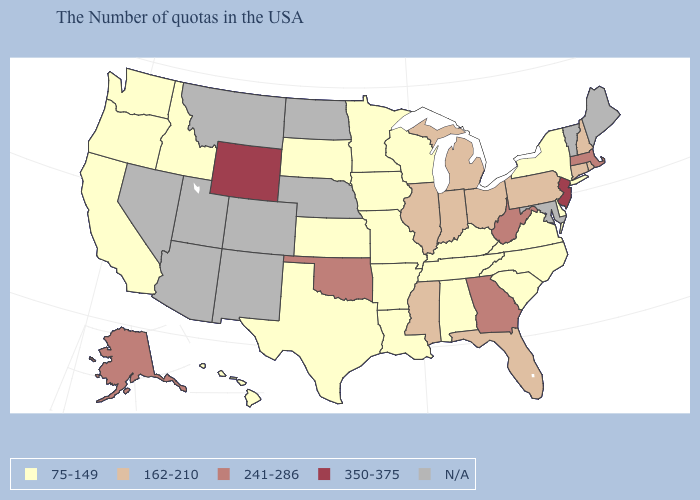Does Washington have the lowest value in the USA?
Give a very brief answer. Yes. What is the value of New Hampshire?
Quick response, please. 162-210. Does the map have missing data?
Quick response, please. Yes. What is the lowest value in the USA?
Quick response, please. 75-149. What is the highest value in states that border Arizona?
Quick response, please. 75-149. What is the value of Vermont?
Concise answer only. N/A. Does New Hampshire have the lowest value in the Northeast?
Answer briefly. No. How many symbols are there in the legend?
Keep it brief. 5. What is the value of Michigan?
Short answer required. 162-210. Among the states that border Nebraska , does Missouri have the lowest value?
Short answer required. Yes. Name the states that have a value in the range N/A?
Concise answer only. Maine, Vermont, Maryland, Nebraska, North Dakota, Colorado, New Mexico, Utah, Montana, Arizona, Nevada. Name the states that have a value in the range 75-149?
Write a very short answer. New York, Delaware, Virginia, North Carolina, South Carolina, Kentucky, Alabama, Tennessee, Wisconsin, Louisiana, Missouri, Arkansas, Minnesota, Iowa, Kansas, Texas, South Dakota, Idaho, California, Washington, Oregon, Hawaii. 